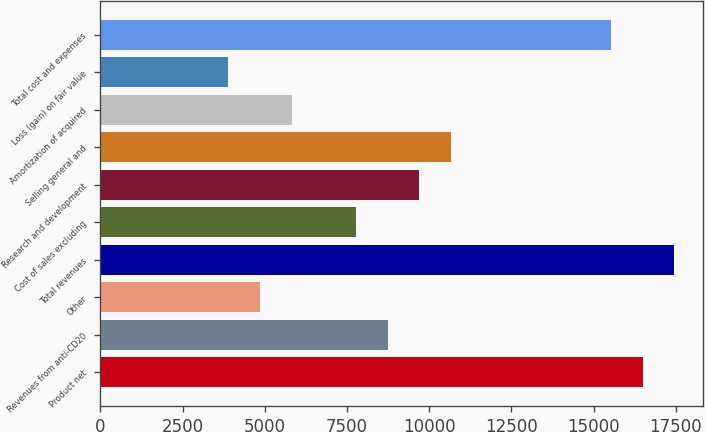<chart> <loc_0><loc_0><loc_500><loc_500><bar_chart><fcel>Product net<fcel>Revenues from anti-CD20<fcel>Other<fcel>Total revenues<fcel>Cost of sales excluding<fcel>Research and development<fcel>Selling general and<fcel>Amortization of acquired<fcel>Loss (gain) on fair value<fcel>Total cost and expenses<nl><fcel>16490.8<fcel>8733.65<fcel>4855.05<fcel>17460.5<fcel>7764<fcel>9703.3<fcel>10673<fcel>5824.7<fcel>3885.4<fcel>15521.2<nl></chart> 